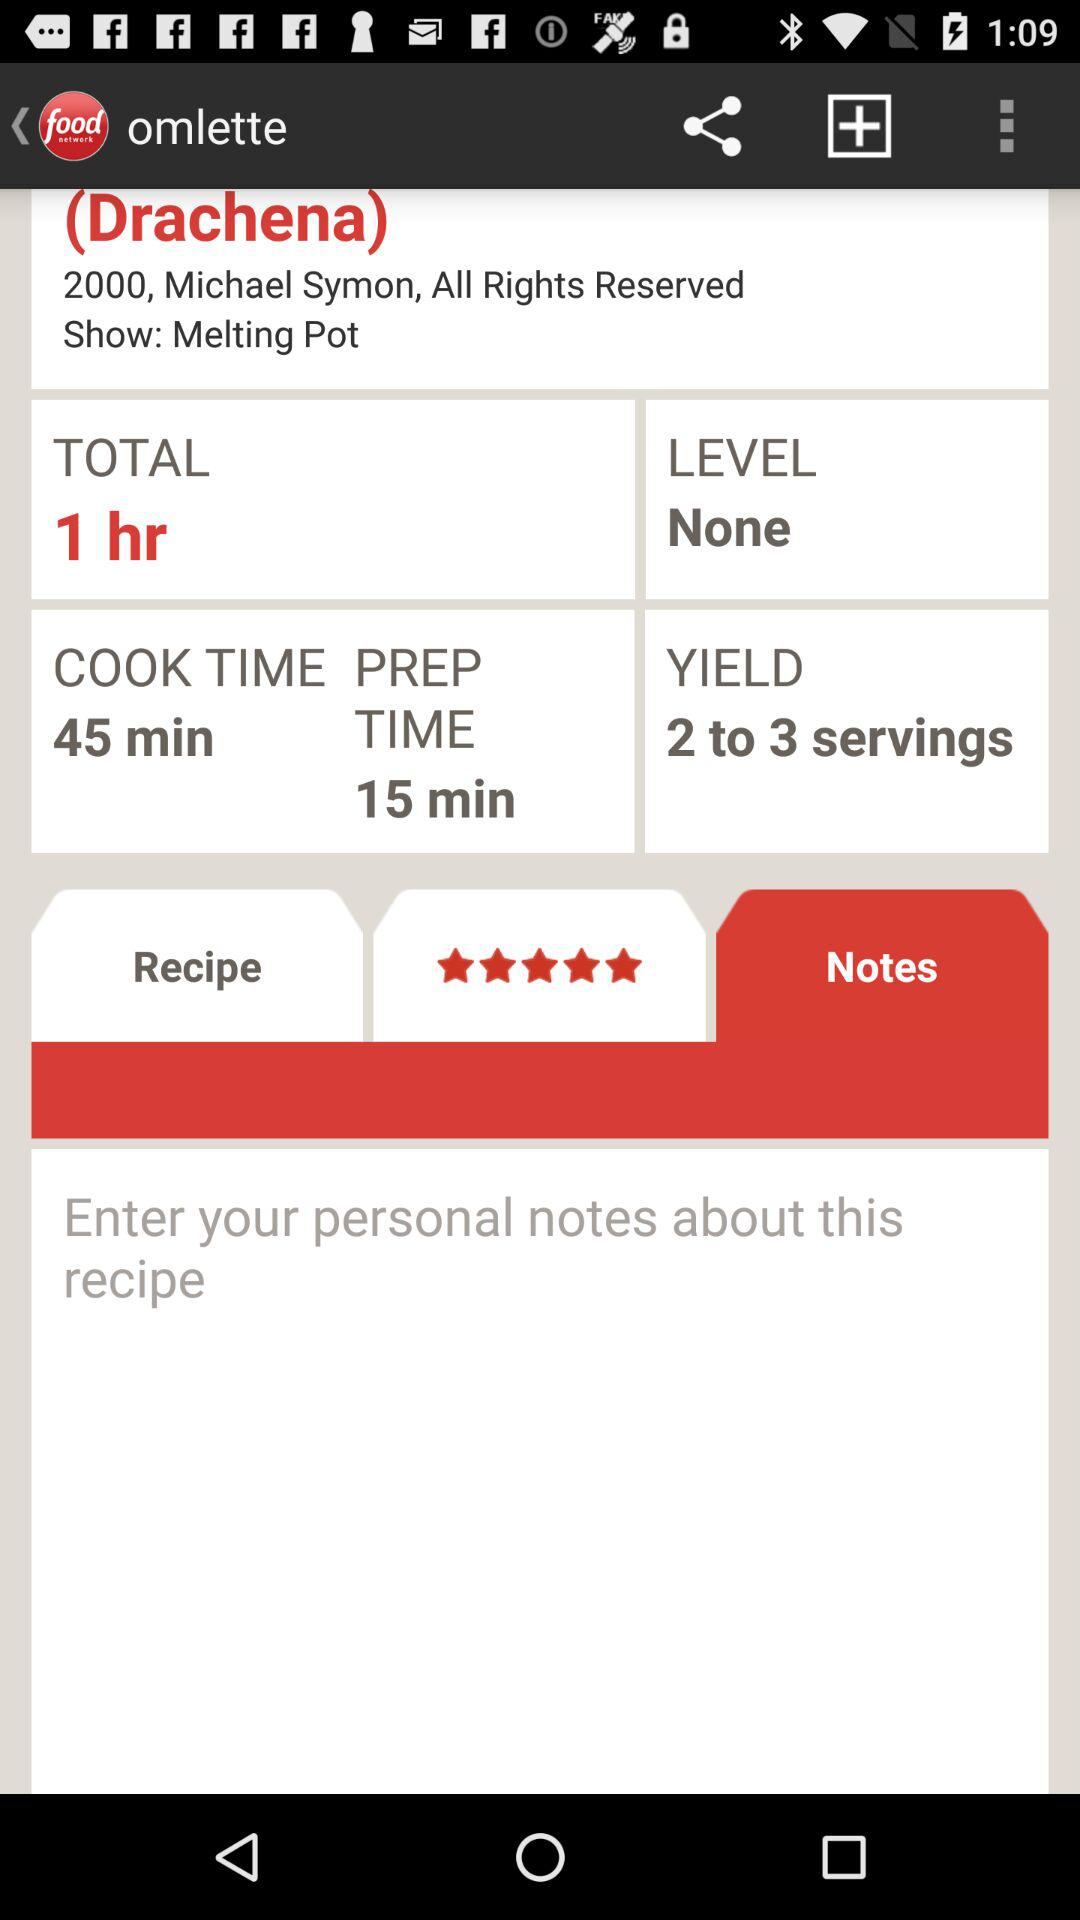How many people are serving? There are 2 to 3 servings. 